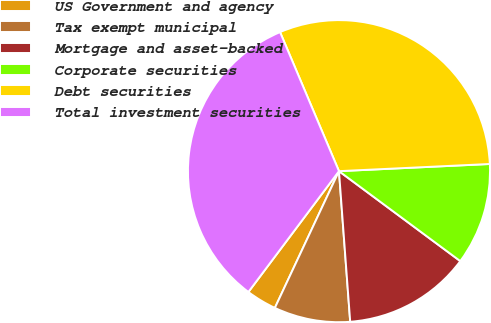Convert chart. <chart><loc_0><loc_0><loc_500><loc_500><pie_chart><fcel>US Government and agency<fcel>Tax exempt municipal<fcel>Mortgage and asset-backed<fcel>Corporate securities<fcel>Debt securities<fcel>Total investment securities<nl><fcel>3.26%<fcel>8.16%<fcel>13.66%<fcel>10.91%<fcel>30.62%<fcel>33.38%<nl></chart> 